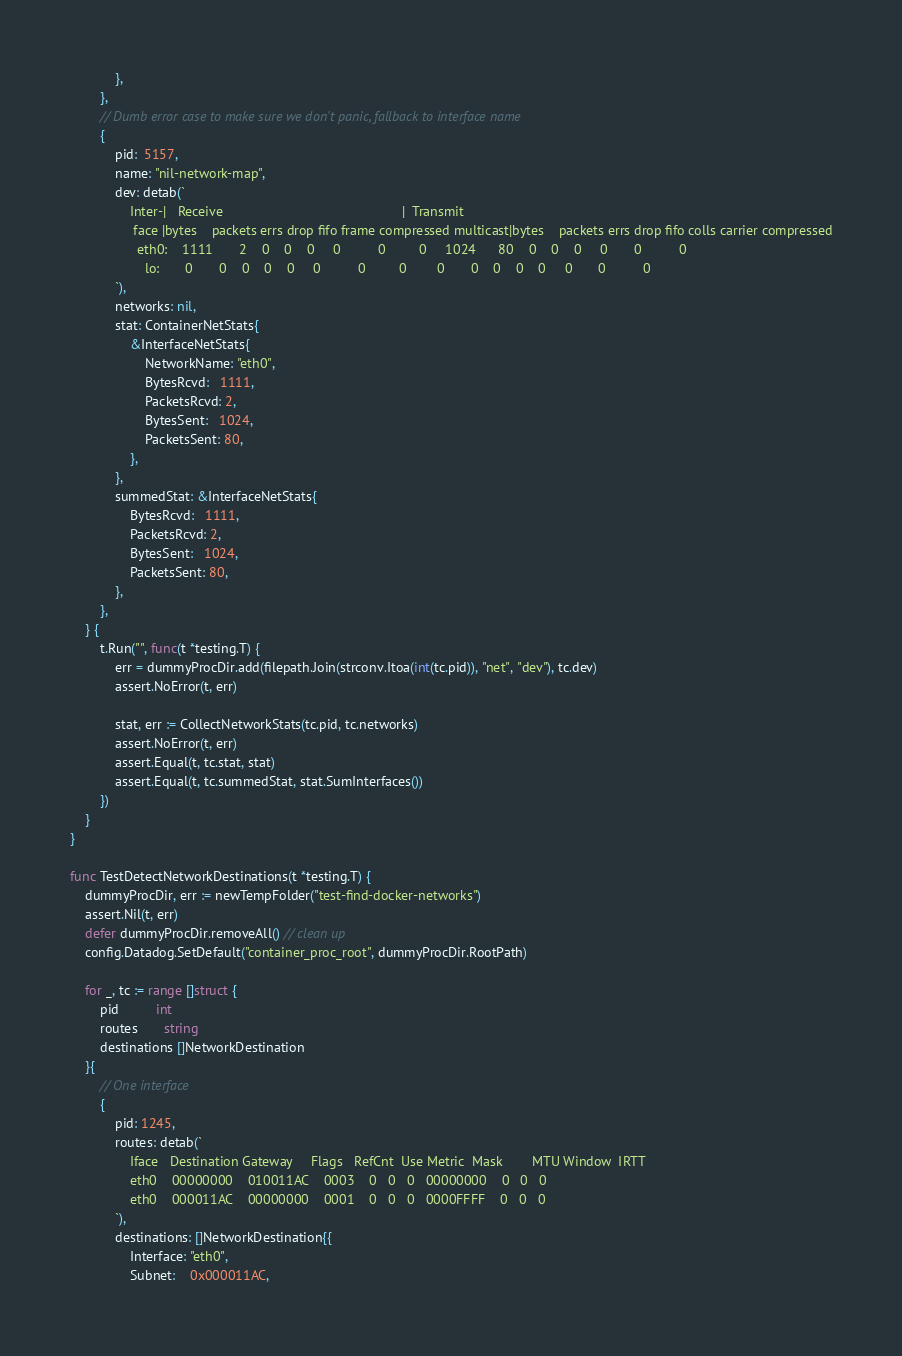<code> <loc_0><loc_0><loc_500><loc_500><_Go_>			},
		},
		// Dumb error case to make sure we don't panic, fallback to interface name
		{
			pid:  5157,
			name: "nil-network-map",
			dev: detab(`
                Inter-|   Receive                                                |  Transmit
                 face |bytes    packets errs drop fifo frame compressed multicast|bytes    packets errs drop fifo colls carrier compressed
                  eth0:    1111       2    0    0    0     0          0         0     1024      80    0    0    0     0       0          0
                    lo:       0       0    0    0    0     0          0         0        0       0    0    0    0     0       0          0
            `),
			networks: nil,
			stat: ContainerNetStats{
				&InterfaceNetStats{
					NetworkName: "eth0",
					BytesRcvd:   1111,
					PacketsRcvd: 2,
					BytesSent:   1024,
					PacketsSent: 80,
				},
			},
			summedStat: &InterfaceNetStats{
				BytesRcvd:   1111,
				PacketsRcvd: 2,
				BytesSent:   1024,
				PacketsSent: 80,
			},
		},
	} {
		t.Run("", func(t *testing.T) {
			err = dummyProcDir.add(filepath.Join(strconv.Itoa(int(tc.pid)), "net", "dev"), tc.dev)
			assert.NoError(t, err)

			stat, err := CollectNetworkStats(tc.pid, tc.networks)
			assert.NoError(t, err)
			assert.Equal(t, tc.stat, stat)
			assert.Equal(t, tc.summedStat, stat.SumInterfaces())
		})
	}
}

func TestDetectNetworkDestinations(t *testing.T) {
	dummyProcDir, err := newTempFolder("test-find-docker-networks")
	assert.Nil(t, err)
	defer dummyProcDir.removeAll() // clean up
	config.Datadog.SetDefault("container_proc_root", dummyProcDir.RootPath)

	for _, tc := range []struct {
		pid          int
		routes       string
		destinations []NetworkDestination
	}{
		// One interface
		{
			pid: 1245,
			routes: detab(`
                Iface   Destination Gateway     Flags   RefCnt  Use Metric  Mask        MTU Window  IRTT
                eth0    00000000    010011AC    0003    0   0   0   00000000    0   0   0
                eth0    000011AC    00000000    0001    0   0   0   0000FFFF    0   0   0
            `),
			destinations: []NetworkDestination{{
				Interface: "eth0",
				Subnet:    0x000011AC,</code> 